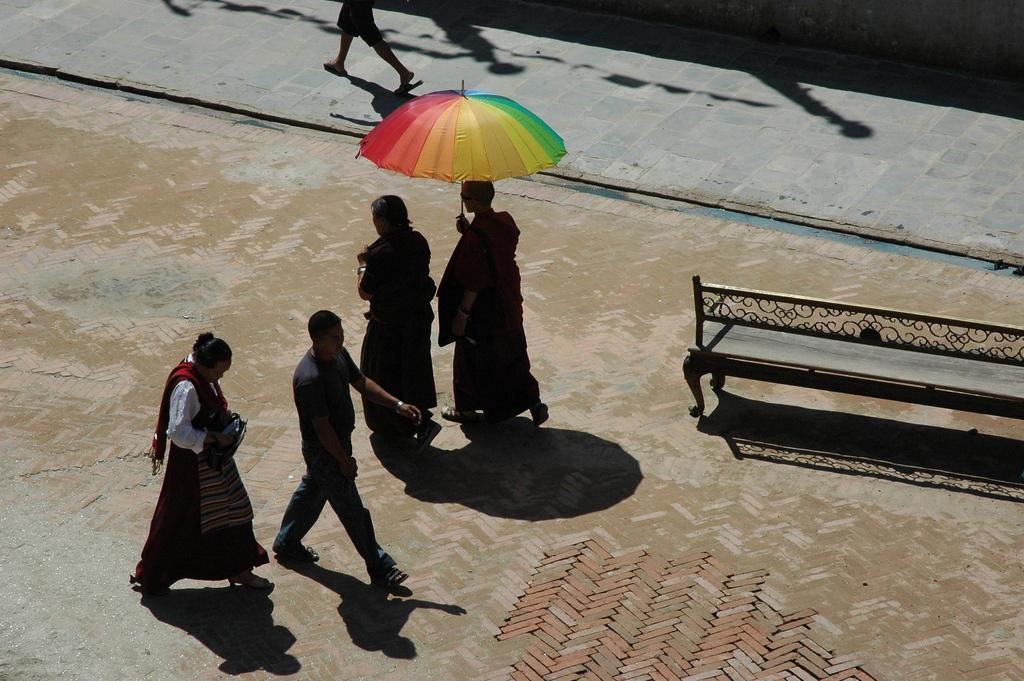Please provide a concise description of this image. In the background we can see the legs of a person on the pathway. In this picture we can see the people walking. We can see a bench. We can see a person is holding an umbrella and walking. 